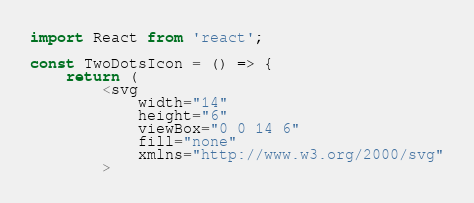<code> <loc_0><loc_0><loc_500><loc_500><_TypeScript_>import React from 'react';

const TwoDotsIcon = () => {
	return (
		<svg
			width="14"
			height="6"
			viewBox="0 0 14 6"
			fill="none"
			xmlns="http://www.w3.org/2000/svg"
		></code> 